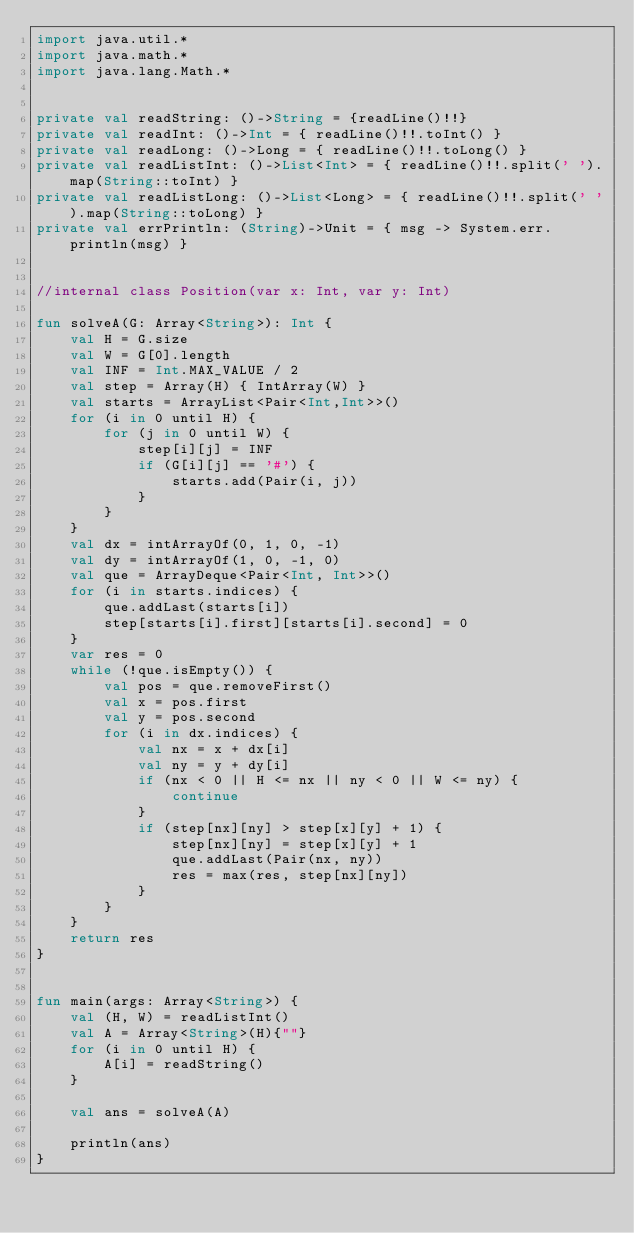<code> <loc_0><loc_0><loc_500><loc_500><_Kotlin_>import java.util.*
import java.math.*
import java.lang.Math.*


private val readString: ()->String = {readLine()!!}
private val readInt: ()->Int = { readLine()!!.toInt() }
private val readLong: ()->Long = { readLine()!!.toLong() }
private val readListInt: ()->List<Int> = { readLine()!!.split(' ').map(String::toInt) }
private val readListLong: ()->List<Long> = { readLine()!!.split(' ').map(String::toLong) }
private val errPrintln: (String)->Unit = { msg -> System.err.println(msg) }


//internal class Position(var x: Int, var y: Int)

fun solveA(G: Array<String>): Int {
    val H = G.size
    val W = G[0].length
    val INF = Int.MAX_VALUE / 2
    val step = Array(H) { IntArray(W) }
    val starts = ArrayList<Pair<Int,Int>>()
    for (i in 0 until H) {
        for (j in 0 until W) {
            step[i][j] = INF
            if (G[i][j] == '#') {
                starts.add(Pair(i, j))
            }
        }
    }
    val dx = intArrayOf(0, 1, 0, -1)
    val dy = intArrayOf(1, 0, -1, 0)
    val que = ArrayDeque<Pair<Int, Int>>()
    for (i in starts.indices) {
        que.addLast(starts[i])
        step[starts[i].first][starts[i].second] = 0
    }
    var res = 0
    while (!que.isEmpty()) {
        val pos = que.removeFirst()
        val x = pos.first
        val y = pos.second
        for (i in dx.indices) {
            val nx = x + dx[i]
            val ny = y + dy[i]
            if (nx < 0 || H <= nx || ny < 0 || W <= ny) {
                continue
            }
            if (step[nx][ny] > step[x][y] + 1) {
                step[nx][ny] = step[x][y] + 1
                que.addLast(Pair(nx, ny))
                res = max(res, step[nx][ny])
            }
        }
    }
    return res
}


fun main(args: Array<String>) {
    val (H, W) = readListInt()
    val A = Array<String>(H){""}
    for (i in 0 until H) {
        A[i] = readString()
    }

    val ans = solveA(A)

    println(ans)
}
</code> 